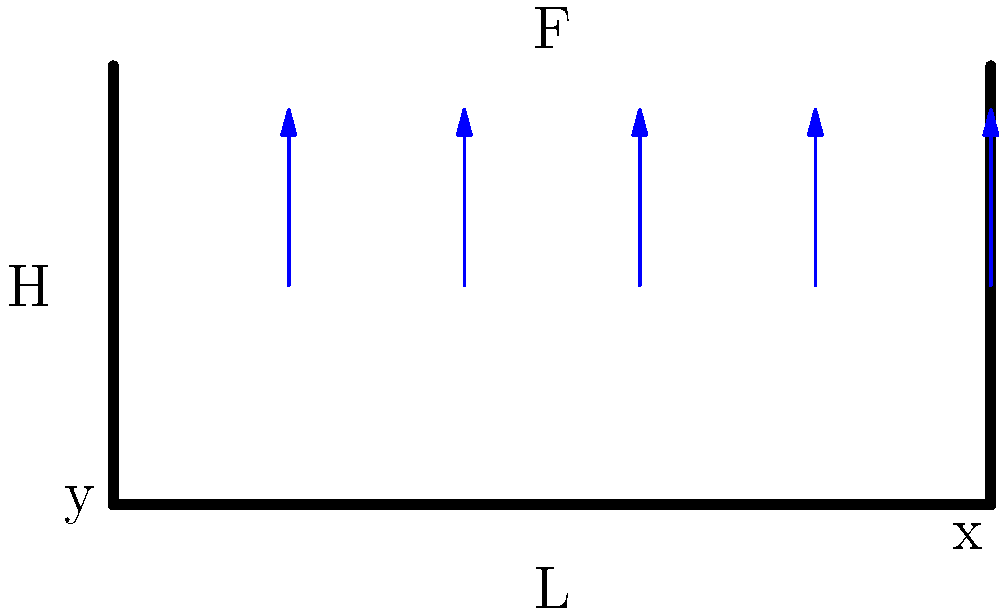A rectangular garden fence of length $L = 10$ m and height $H = 2$ m is subjected to a uniform wind load of $F = 500$ N/m². Assuming the fence behaves as a simply supported beam, calculate the maximum bending moment $M_{max}$ at the center of the fence. Use the formula $M_{max} = \frac{wL^2}{8}$, where $w$ is the distributed load per unit length. To solve this problem, we'll follow these steps:

1. Calculate the distributed load $w$:
   The wind load $F$ is given in N/m², but we need it in N/m.
   $w = F \times H = 500 \text{ N/m²} \times 2 \text{ m} = 1000 \text{ N/m}$

2. Apply the formula for maximum bending moment:
   $M_{max} = \frac{wL^2}{8}$

3. Substitute the values:
   $L = 10 \text{ m}$
   $w = 1000 \text{ N/m}$

4. Calculate:
   $M_{max} = \frac{1000 \text{ N/m} \times (10 \text{ m})^2}{8} = \frac{100,000 \text{ N} \cdot \text{m}}{8} = 12,500 \text{ N} \cdot \text{m}$

Therefore, the maximum bending moment at the center of the fence is 12,500 N⋅m.
Answer: 12,500 N⋅m 